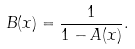<formula> <loc_0><loc_0><loc_500><loc_500>B ( x ) = \frac { 1 } { 1 - A ( x ) } .</formula> 